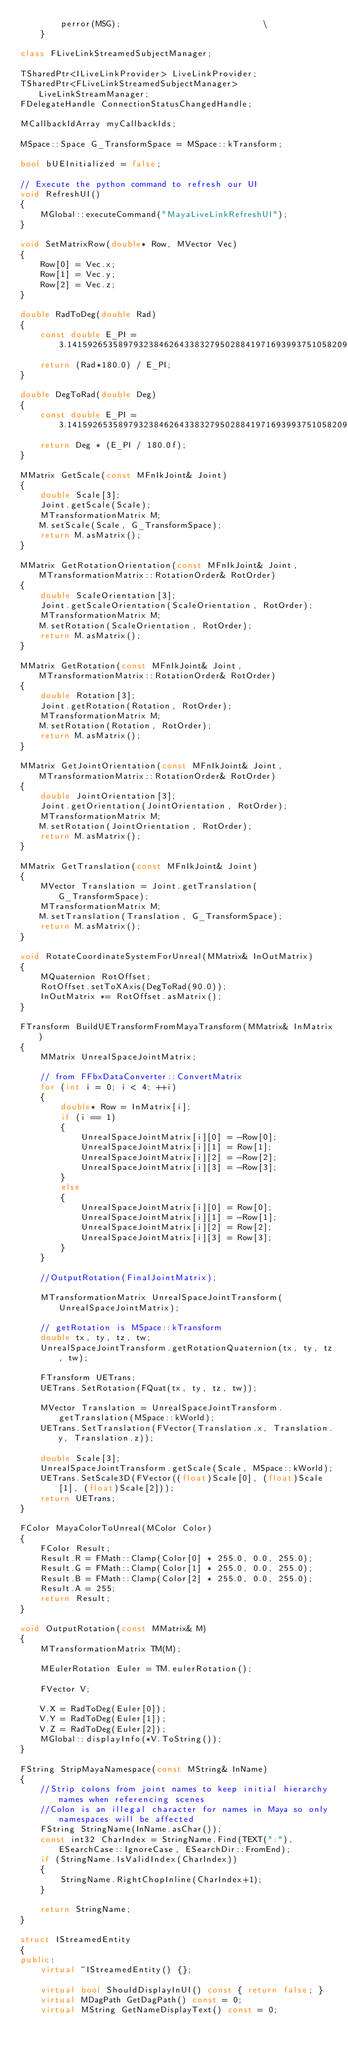<code> <loc_0><loc_0><loc_500><loc_500><_C++_>        perror(MSG);                            \
    }

class FLiveLinkStreamedSubjectManager;

TSharedPtr<ILiveLinkProvider> LiveLinkProvider;
TSharedPtr<FLiveLinkStreamedSubjectManager> LiveLinkStreamManager;
FDelegateHandle ConnectionStatusChangedHandle;

MCallbackIdArray myCallbackIds;

MSpace::Space G_TransformSpace = MSpace::kTransform;

bool bUEInitialized = false;

// Execute the python command to refresh our UI
void RefreshUI()
{
	MGlobal::executeCommand("MayaLiveLinkRefreshUI");
}

void SetMatrixRow(double* Row, MVector Vec)
{
	Row[0] = Vec.x;
	Row[1] = Vec.y;
	Row[2] = Vec.z;
}

double RadToDeg(double Rad)
{
	const double E_PI = 3.1415926535897932384626433832795028841971693993751058209749445923078164062;
	return (Rad*180.0) / E_PI;
}

double DegToRad(double Deg)
{
	const double E_PI = 3.1415926535897932384626433832795028841971693993751058209749445923078164062;
	return Deg * (E_PI / 180.0f);
}

MMatrix GetScale(const MFnIkJoint& Joint)
{
	double Scale[3];
	Joint.getScale(Scale);
	MTransformationMatrix M;
	M.setScale(Scale, G_TransformSpace);
	return M.asMatrix();
}

MMatrix GetRotationOrientation(const MFnIkJoint& Joint, MTransformationMatrix::RotationOrder& RotOrder)
{
	double ScaleOrientation[3];
	Joint.getScaleOrientation(ScaleOrientation, RotOrder);
	MTransformationMatrix M;
	M.setRotation(ScaleOrientation, RotOrder);
	return M.asMatrix();
}

MMatrix GetRotation(const MFnIkJoint& Joint, MTransformationMatrix::RotationOrder& RotOrder)
{
	double Rotation[3];
	Joint.getRotation(Rotation, RotOrder);
	MTransformationMatrix M;
	M.setRotation(Rotation, RotOrder);
	return M.asMatrix();
}

MMatrix GetJointOrientation(const MFnIkJoint& Joint, MTransformationMatrix::RotationOrder& RotOrder)
{
	double JointOrientation[3];
	Joint.getOrientation(JointOrientation, RotOrder);
	MTransformationMatrix M;
	M.setRotation(JointOrientation, RotOrder);
	return M.asMatrix();
}

MMatrix GetTranslation(const MFnIkJoint& Joint)
{
	MVector Translation = Joint.getTranslation(G_TransformSpace);
	MTransformationMatrix M;
	M.setTranslation(Translation, G_TransformSpace);
	return M.asMatrix();
}

void RotateCoordinateSystemForUnreal(MMatrix& InOutMatrix)
{
	MQuaternion RotOffset;
	RotOffset.setToXAxis(DegToRad(90.0));
	InOutMatrix *= RotOffset.asMatrix();
}

FTransform BuildUETransformFromMayaTransform(MMatrix& InMatrix)
{
	MMatrix UnrealSpaceJointMatrix;

	// from FFbxDataConverter::ConvertMatrix
	for (int i = 0; i < 4; ++i)
	{
		double* Row = InMatrix[i];
		if (i == 1)
		{
			UnrealSpaceJointMatrix[i][0] = -Row[0];
			UnrealSpaceJointMatrix[i][1] = Row[1];
			UnrealSpaceJointMatrix[i][2] = -Row[2];
			UnrealSpaceJointMatrix[i][3] = -Row[3];
		}
		else
		{
			UnrealSpaceJointMatrix[i][0] = Row[0];
			UnrealSpaceJointMatrix[i][1] = -Row[1];
			UnrealSpaceJointMatrix[i][2] = Row[2];
			UnrealSpaceJointMatrix[i][3] = Row[3];
		}
	}

	//OutputRotation(FinalJointMatrix);

	MTransformationMatrix UnrealSpaceJointTransform(UnrealSpaceJointMatrix);

	// getRotation is MSpace::kTransform
	double tx, ty, tz, tw;
	UnrealSpaceJointTransform.getRotationQuaternion(tx, ty, tz, tw);

	FTransform UETrans;
	UETrans.SetRotation(FQuat(tx, ty, tz, tw));

	MVector Translation = UnrealSpaceJointTransform.getTranslation(MSpace::kWorld);
	UETrans.SetTranslation(FVector(Translation.x, Translation.y, Translation.z));

	double Scale[3];
	UnrealSpaceJointTransform.getScale(Scale, MSpace::kWorld);
	UETrans.SetScale3D(FVector((float)Scale[0], (float)Scale[1], (float)Scale[2]));
	return UETrans;
}

FColor MayaColorToUnreal(MColor Color)
{
	FColor Result;
	Result.R = FMath::Clamp(Color[0] * 255.0, 0.0, 255.0);
	Result.G = FMath::Clamp(Color[1] * 255.0, 0.0, 255.0);
	Result.B = FMath::Clamp(Color[2] * 255.0, 0.0, 255.0);
	Result.A = 255;
	return Result;
}

void OutputRotation(const MMatrix& M)
{
	MTransformationMatrix TM(M);

	MEulerRotation Euler = TM.eulerRotation();

	FVector V;

	V.X = RadToDeg(Euler[0]);
	V.Y = RadToDeg(Euler[1]);
	V.Z = RadToDeg(Euler[2]);
	MGlobal::displayInfo(*V.ToString());
}

FString StripMayaNamespace(const MString& InName)
{
	//Strip colons from joint names to keep initial hierarchy names when referencing scenes
	//Colon is an illegal character for names in Maya so only namespaces will be affected
	FString StringName(InName.asChar());
	const int32 CharIndex = StringName.Find(TEXT(":"), ESearchCase::IgnoreCase, ESearchDir::FromEnd);
	if (StringName.IsValidIndex(CharIndex))
	{
		StringName.RightChopInline(CharIndex+1);
	}

	return StringName;
}

struct IStreamedEntity
{
public:
	virtual ~IStreamedEntity() {};

	virtual bool ShouldDisplayInUI() const { return false; }
	virtual MDagPath GetDagPath() const = 0;
	virtual MString GetNameDisplayText() const = 0;</code> 